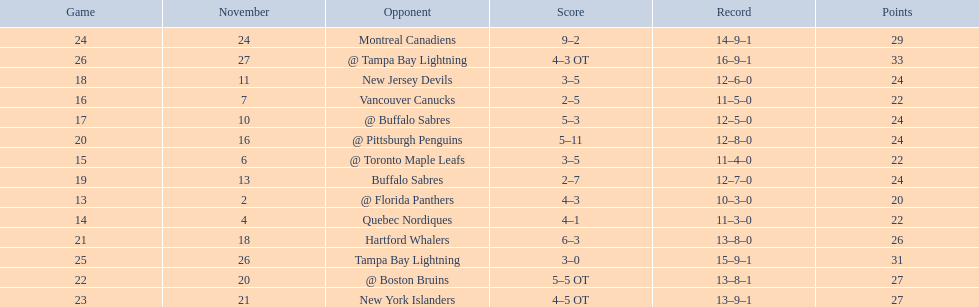Who are all of the teams? @ Florida Panthers, Quebec Nordiques, @ Toronto Maple Leafs, Vancouver Canucks, @ Buffalo Sabres, New Jersey Devils, Buffalo Sabres, @ Pittsburgh Penguins, Hartford Whalers, @ Boston Bruins, New York Islanders, Montreal Canadiens, Tampa Bay Lightning. What games finished in overtime? 22, 23, 26. In game number 23, who did they face? New York Islanders. 